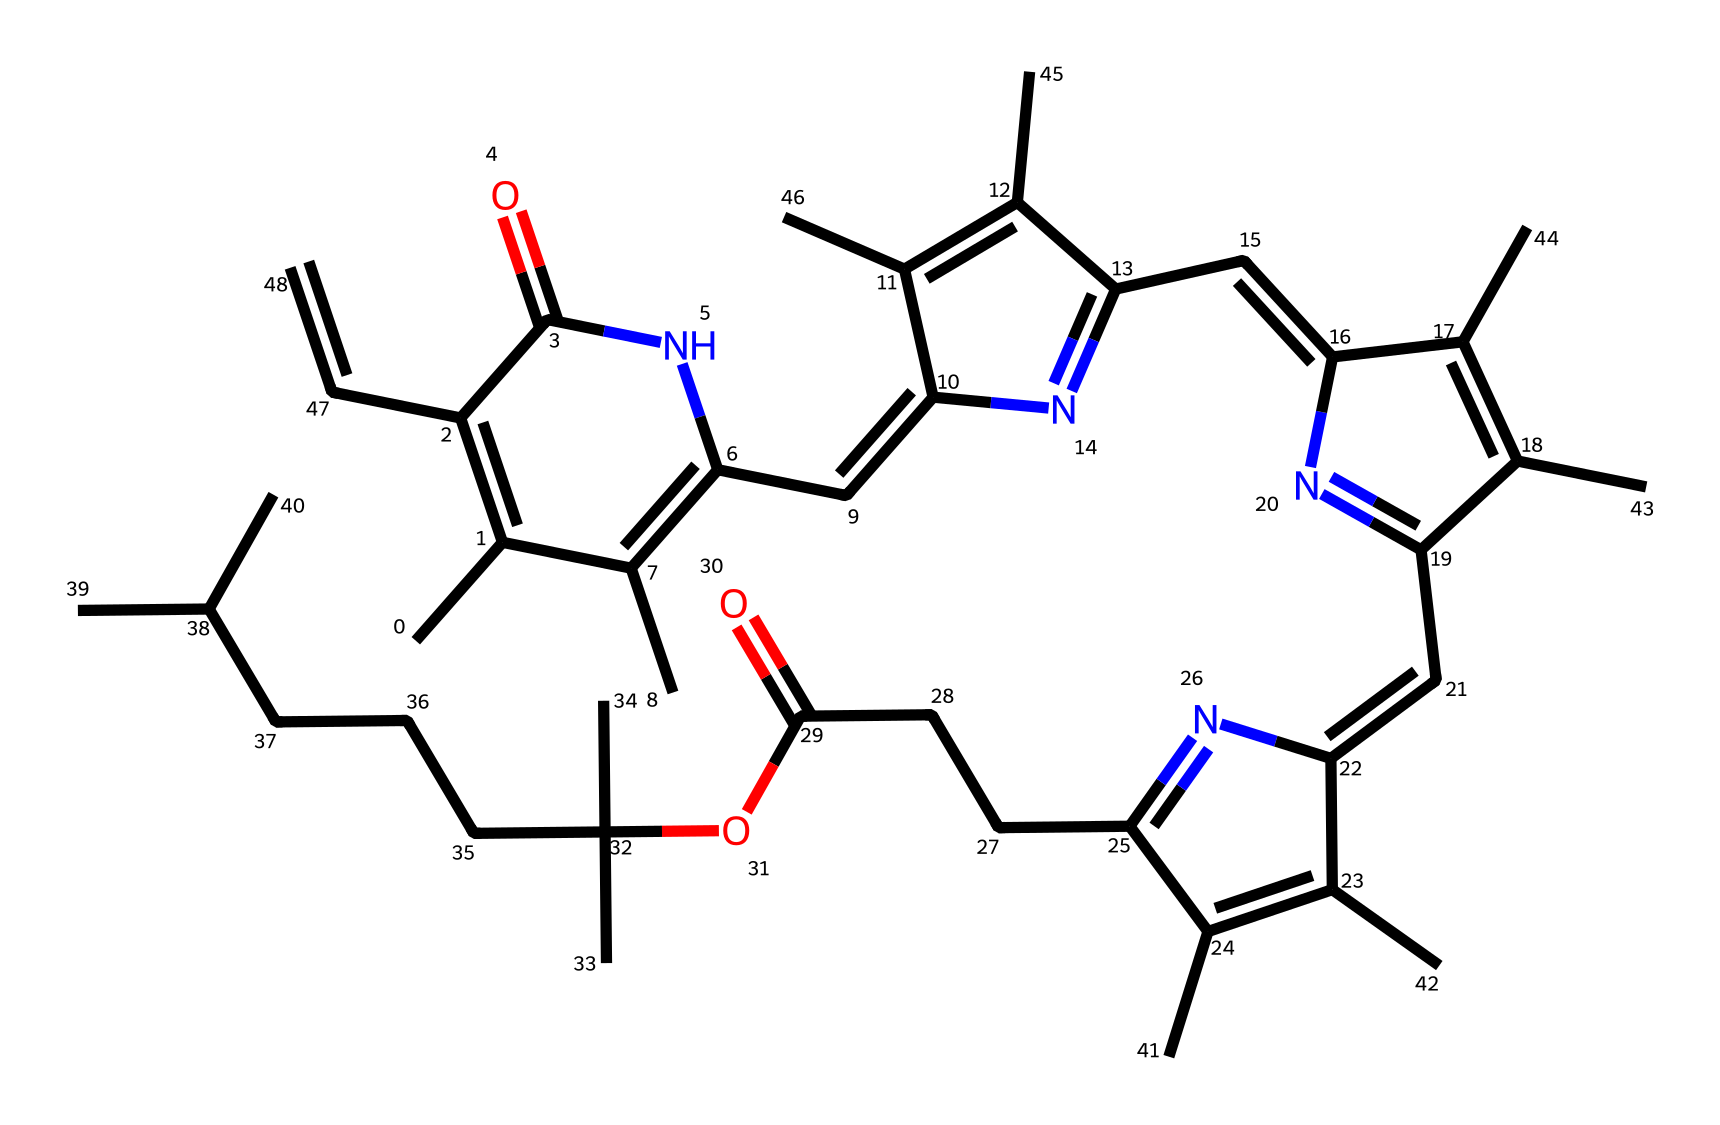What is the primary functional group present in this molecular structure? The structure contains multiple carbon atoms bonded to nitrogen and oxygen, indicating the presence of amides and esters. The presence of the carbonyl group (C=O) attached to nitrogen atoms indicates amide functional groups.
Answer: amide How many nitrogen atoms are present in this molecule? By examining the SMILES representation, we can count the 'N' characters, which represent nitrogen atoms. There are five nitrogen atoms in the structure.
Answer: five Is this molecule likely to be hydrophilic or hydrophobic? The presence of multiple carbon atoms, especially those forming long alkyl chains and aromatic rings, suggests a hydrophobic character. The molecule lacks significant polar functional groups, which tend to increase hydrophilicity.
Answer: hydrophobic What aspect of this molecule contributes to its light sensitivity? The conjugated double bonds in the cyclic structure allow for delocalization of electrons, which is critical in absorbing light and leading to light-sensitive behavior in pigments like chlorophyll.
Answer: conjugated double bonds Which part of the molecule is most likely responsible for its pigment properties? The conjugated system formed by the alternating double and single bonds within the cyclic structures facilitates light absorption, giving chlorophyll its pigment properties necessary for photosynthesis.
Answer: conjugated system 